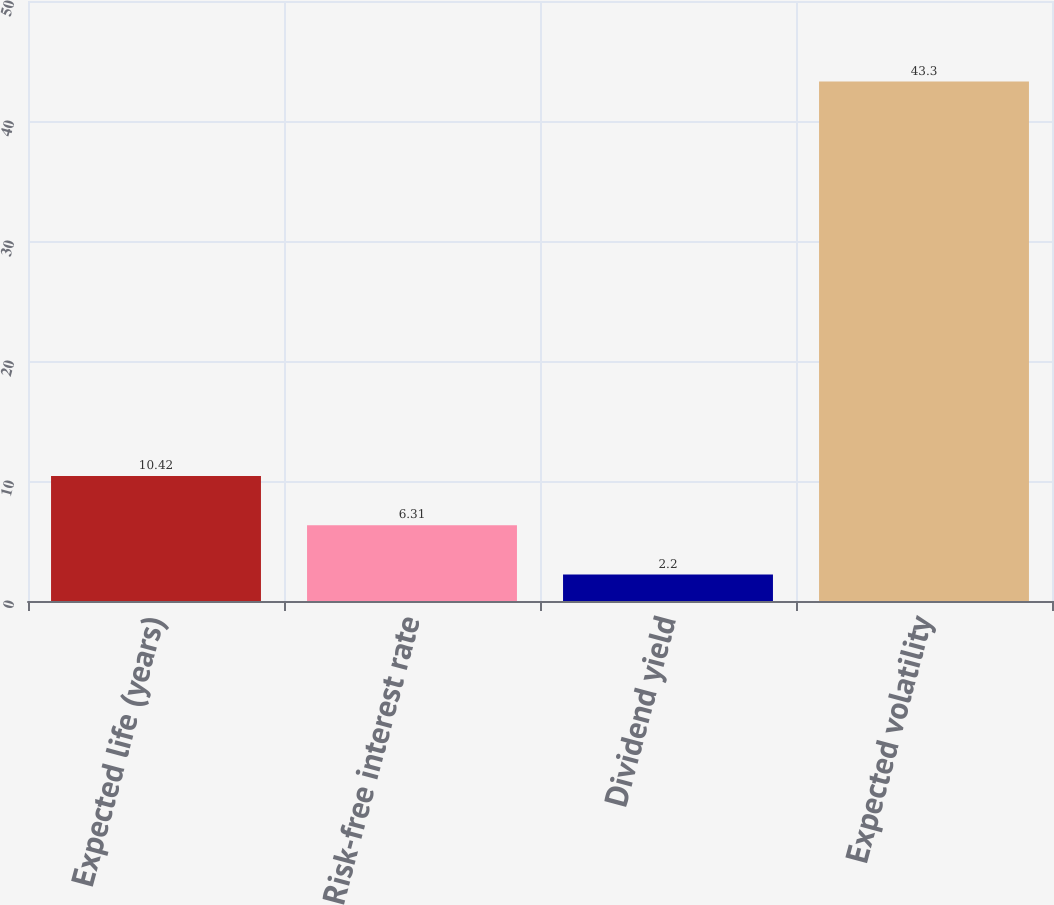Convert chart. <chart><loc_0><loc_0><loc_500><loc_500><bar_chart><fcel>Expected life (years)<fcel>Risk-free interest rate<fcel>Dividend yield<fcel>Expected volatility<nl><fcel>10.42<fcel>6.31<fcel>2.2<fcel>43.3<nl></chart> 